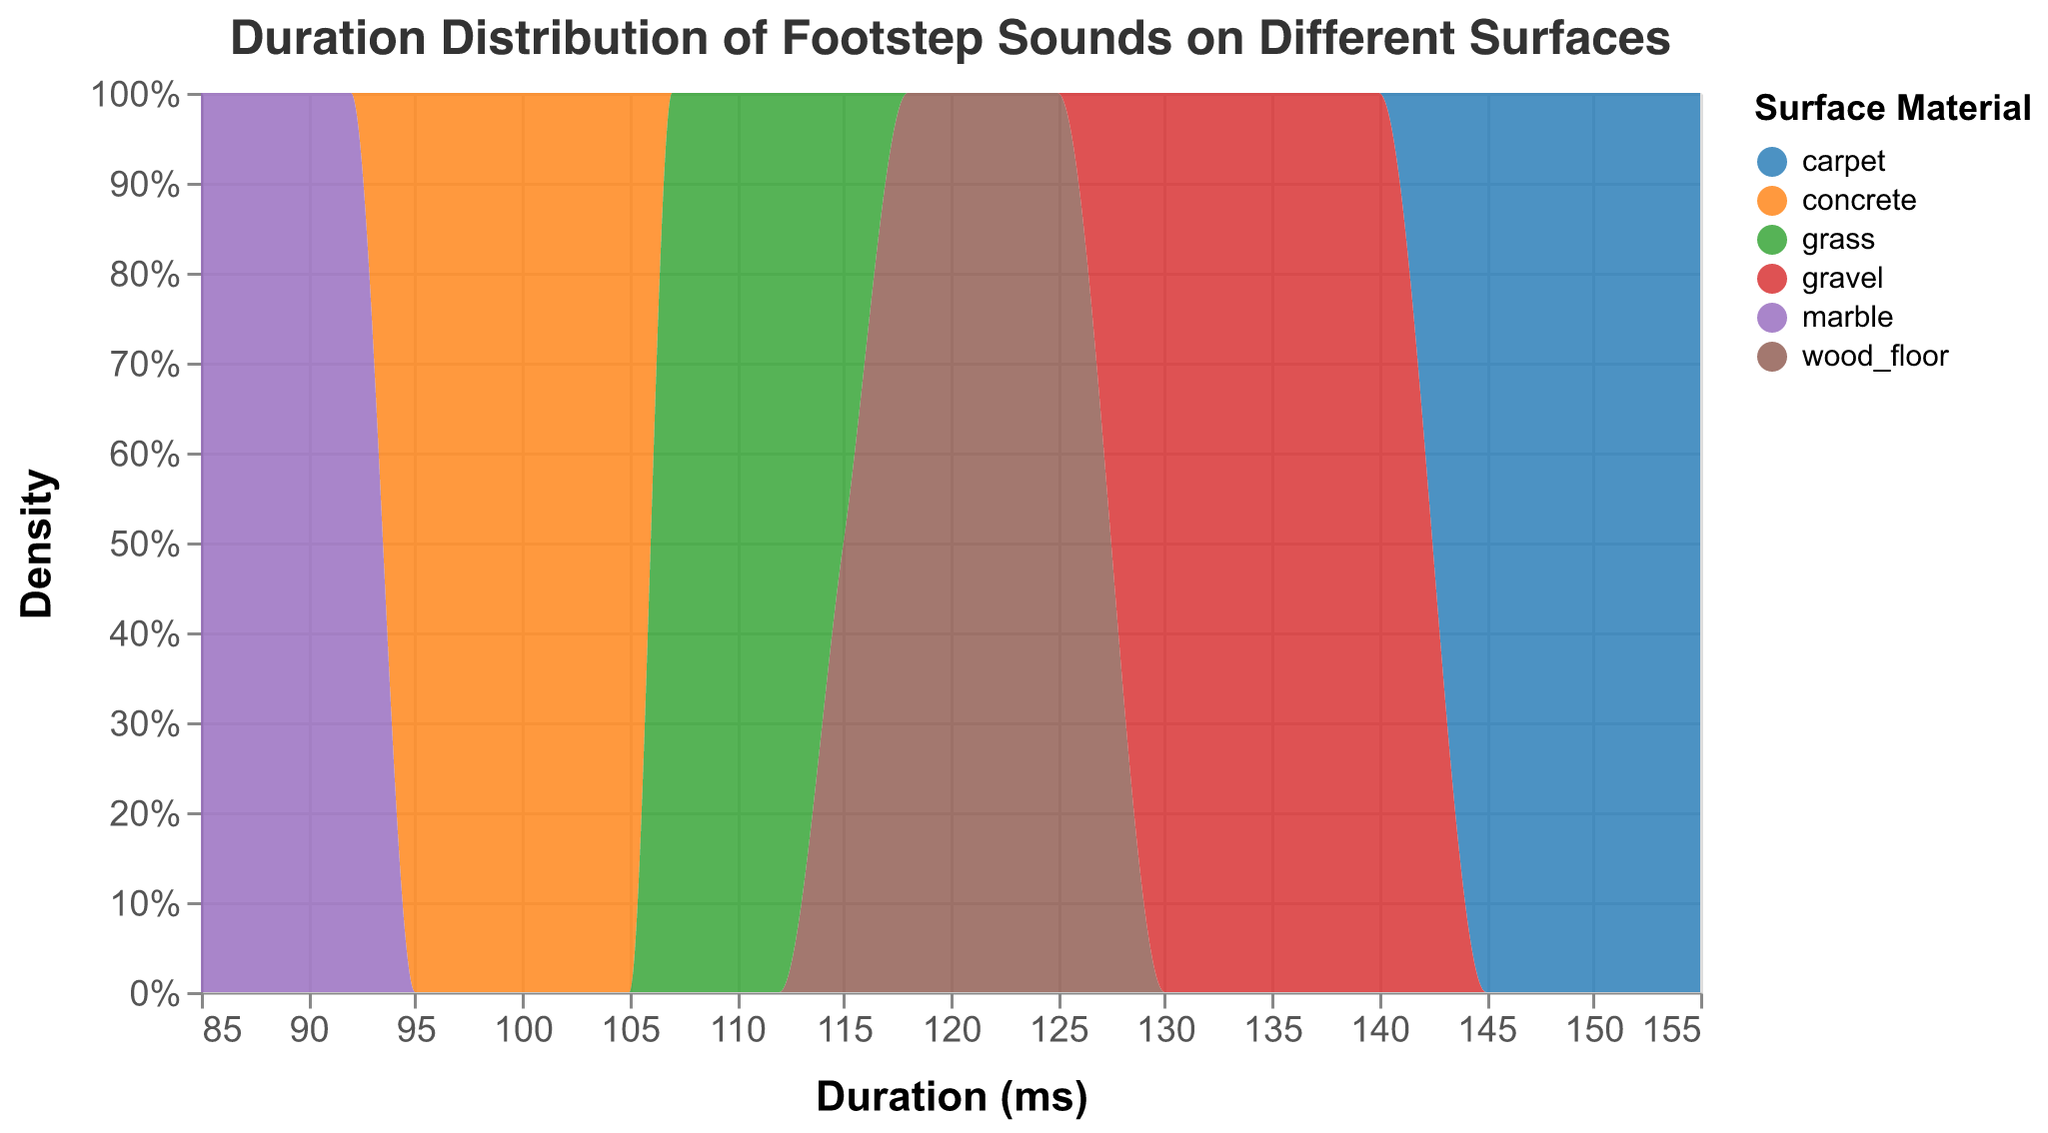How many surface materials are displayed in the figure? The color legend shows different surface materials, each associated with a unique color. Count the different color categories in the legend.
Answer: 6 Which surface material shows the shortest duration for footstep sounds? Identify the surface material that has the highest density near the lower end of the x-axis (duration in ms). In the plot, look for the surface material near the leftmost part of the x-axis.
Answer: marble What is the approximate range of durations for footsteps on carpeted surfaces? Identify the section of the x-axis where the density area representing 'carpet' spans. Observe the boundaries on the x-axis for the 'carpet' section.
Answer: 145 ms - 155 ms Do footsteps on grass have a higher density at higher durations compared to concrete? Compare the density areas of 'grass' and 'concrete' by looking at their positions along the x-axis. Check where 'grass' has a significant density compared to 'concrete'.
Answer: Yes Which surface material has the most spread-out distribution of footstep durations? Look at the width of the density areas along the x-axis for each surface material. The one with the widest span denotes the most spread-out distribution.
Answer: wood_floor Are footsteps on gravel generally of lesser or greater duration compared to those on marble? Compare the density peaks of 'gravel' and 'marble' on the x-axis. Determine whether the peak for 'gravel' occurs at a longer or shorter duration than 'marble'.
Answer: Greater What percentage density does wood floor footprint sounds achieve at its peak? Look at the highest point of the density area for 'wood_floor' on the y-axis. This peak represents the density percentage.
Answer: Approximately 20% For which surface material is the duration spread from ~85 ms to ~130 ms? Examine the x-axis range for each surface material and see which material spans from about 85 ms to 130 ms.
Answer: marble and gravel Is the duration distribution for footstep sounds on concrete heavily concentrated or spread out? Look at the density area for 'concrete' along the x-axis. If the density area is narrow, it is concentrated; if wide, it is spread out.
Answer: Concentrated 